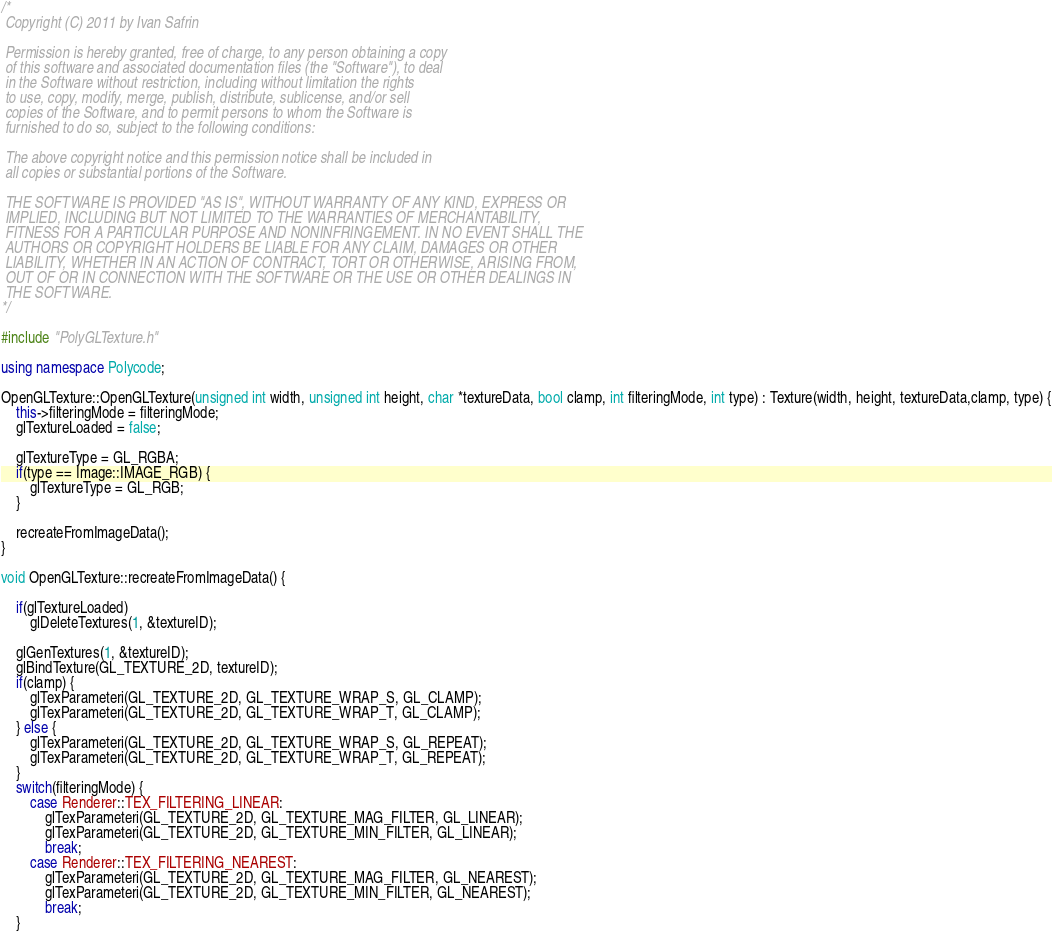Convert code to text. <code><loc_0><loc_0><loc_500><loc_500><_C++_>/*
 Copyright (C) 2011 by Ivan Safrin
 
 Permission is hereby granted, free of charge, to any person obtaining a copy
 of this software and associated documentation files (the "Software"), to deal
 in the Software without restriction, including without limitation the rights
 to use, copy, modify, merge, publish, distribute, sublicense, and/or sell
 copies of the Software, and to permit persons to whom the Software is
 furnished to do so, subject to the following conditions:
 
 The above copyright notice and this permission notice shall be included in
 all copies or substantial portions of the Software.
 
 THE SOFTWARE IS PROVIDED "AS IS", WITHOUT WARRANTY OF ANY KIND, EXPRESS OR
 IMPLIED, INCLUDING BUT NOT LIMITED TO THE WARRANTIES OF MERCHANTABILITY,
 FITNESS FOR A PARTICULAR PURPOSE AND NONINFRINGEMENT. IN NO EVENT SHALL THE
 AUTHORS OR COPYRIGHT HOLDERS BE LIABLE FOR ANY CLAIM, DAMAGES OR OTHER
 LIABILITY, WHETHER IN AN ACTION OF CONTRACT, TORT OR OTHERWISE, ARISING FROM,
 OUT OF OR IN CONNECTION WITH THE SOFTWARE OR THE USE OR OTHER DEALINGS IN
 THE SOFTWARE.
*/

#include "PolyGLTexture.h"

using namespace Polycode;

OpenGLTexture::OpenGLTexture(unsigned int width, unsigned int height, char *textureData, bool clamp, int filteringMode, int type) : Texture(width, height, textureData,clamp, type) {
	this->filteringMode = filteringMode;
	glTextureLoaded = false;
	
	glTextureType = GL_RGBA;
	if(type == Image::IMAGE_RGB) {
		glTextureType = GL_RGB;		
	} 
	
	recreateFromImageData();
}

void OpenGLTexture::recreateFromImageData() {
	
	if(glTextureLoaded)
		glDeleteTextures(1, &textureID);
	
	glGenTextures(1, &textureID);
	glBindTexture(GL_TEXTURE_2D, textureID);
	if(clamp) {
		glTexParameteri(GL_TEXTURE_2D, GL_TEXTURE_WRAP_S, GL_CLAMP);
		glTexParameteri(GL_TEXTURE_2D, GL_TEXTURE_WRAP_T, GL_CLAMP);
	} else {
		glTexParameteri(GL_TEXTURE_2D, GL_TEXTURE_WRAP_S, GL_REPEAT);
		glTexParameteri(GL_TEXTURE_2D, GL_TEXTURE_WRAP_T, GL_REPEAT);	
	}
	switch(filteringMode) {
		case Renderer::TEX_FILTERING_LINEAR:
			glTexParameteri(GL_TEXTURE_2D, GL_TEXTURE_MAG_FILTER, GL_LINEAR);
			glTexParameteri(GL_TEXTURE_2D, GL_TEXTURE_MIN_FILTER, GL_LINEAR);
			break;
		case Renderer::TEX_FILTERING_NEAREST:
			glTexParameteri(GL_TEXTURE_2D, GL_TEXTURE_MAG_FILTER, GL_NEAREST);
			glTexParameteri(GL_TEXTURE_2D, GL_TEXTURE_MIN_FILTER, GL_NEAREST);		
			break;
	}	</code> 